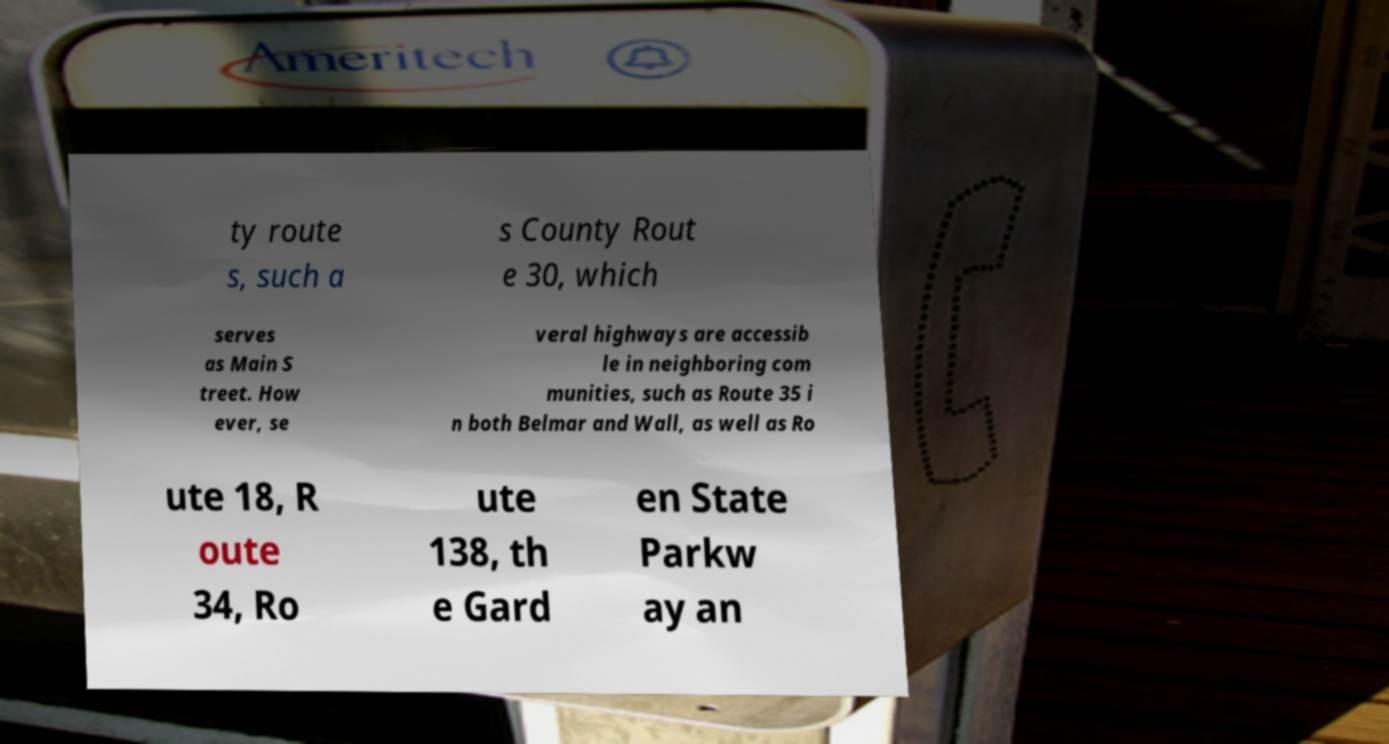Can you accurately transcribe the text from the provided image for me? ty route s, such a s County Rout e 30, which serves as Main S treet. How ever, se veral highways are accessib le in neighboring com munities, such as Route 35 i n both Belmar and Wall, as well as Ro ute 18, R oute 34, Ro ute 138, th e Gard en State Parkw ay an 